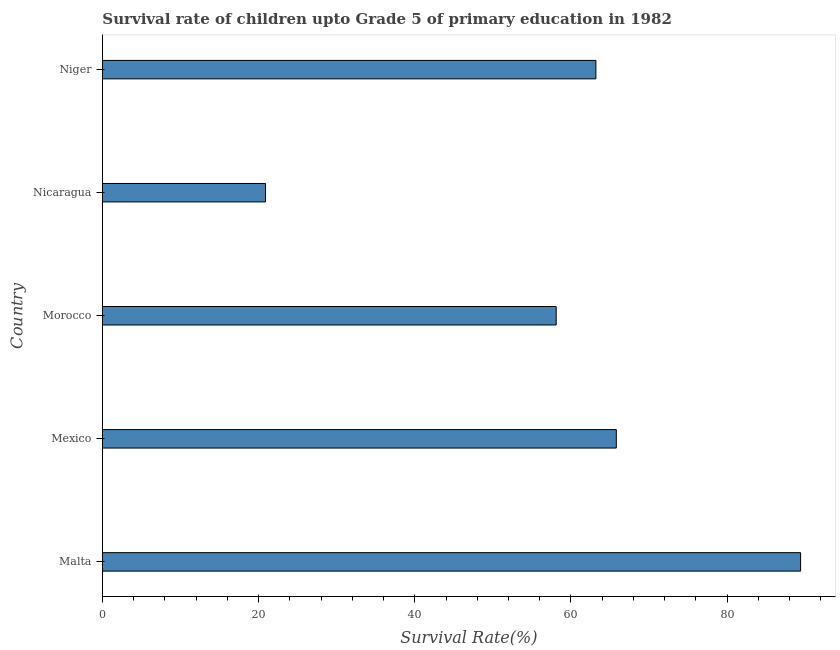Does the graph contain any zero values?
Give a very brief answer. No. Does the graph contain grids?
Your answer should be very brief. No. What is the title of the graph?
Offer a terse response. Survival rate of children upto Grade 5 of primary education in 1982 . What is the label or title of the X-axis?
Ensure brevity in your answer.  Survival Rate(%). What is the survival rate in Niger?
Ensure brevity in your answer.  63.19. Across all countries, what is the maximum survival rate?
Your answer should be compact. 89.4. Across all countries, what is the minimum survival rate?
Provide a short and direct response. 20.88. In which country was the survival rate maximum?
Your answer should be compact. Malta. In which country was the survival rate minimum?
Keep it short and to the point. Nicaragua. What is the sum of the survival rate?
Your answer should be compact. 297.39. What is the difference between the survival rate in Mexico and Niger?
Keep it short and to the point. 2.62. What is the average survival rate per country?
Keep it short and to the point. 59.48. What is the median survival rate?
Your answer should be very brief. 63.19. In how many countries, is the survival rate greater than 24 %?
Your answer should be compact. 4. What is the ratio of the survival rate in Morocco to that in Nicaragua?
Offer a very short reply. 2.78. Is the survival rate in Mexico less than that in Nicaragua?
Your response must be concise. No. What is the difference between the highest and the second highest survival rate?
Your answer should be very brief. 23.6. What is the difference between the highest and the lowest survival rate?
Make the answer very short. 68.52. How many bars are there?
Your response must be concise. 5. How many countries are there in the graph?
Make the answer very short. 5. What is the difference between two consecutive major ticks on the X-axis?
Ensure brevity in your answer.  20. Are the values on the major ticks of X-axis written in scientific E-notation?
Your response must be concise. No. What is the Survival Rate(%) in Malta?
Your answer should be compact. 89.4. What is the Survival Rate(%) in Mexico?
Your answer should be very brief. 65.81. What is the Survival Rate(%) in Morocco?
Your response must be concise. 58.11. What is the Survival Rate(%) in Nicaragua?
Your response must be concise. 20.88. What is the Survival Rate(%) of Niger?
Ensure brevity in your answer.  63.19. What is the difference between the Survival Rate(%) in Malta and Mexico?
Your answer should be very brief. 23.6. What is the difference between the Survival Rate(%) in Malta and Morocco?
Provide a short and direct response. 31.3. What is the difference between the Survival Rate(%) in Malta and Nicaragua?
Ensure brevity in your answer.  68.52. What is the difference between the Survival Rate(%) in Malta and Niger?
Offer a very short reply. 26.22. What is the difference between the Survival Rate(%) in Mexico and Morocco?
Provide a succinct answer. 7.7. What is the difference between the Survival Rate(%) in Mexico and Nicaragua?
Give a very brief answer. 44.93. What is the difference between the Survival Rate(%) in Mexico and Niger?
Give a very brief answer. 2.62. What is the difference between the Survival Rate(%) in Morocco and Nicaragua?
Provide a succinct answer. 37.23. What is the difference between the Survival Rate(%) in Morocco and Niger?
Your response must be concise. -5.08. What is the difference between the Survival Rate(%) in Nicaragua and Niger?
Make the answer very short. -42.31. What is the ratio of the Survival Rate(%) in Malta to that in Mexico?
Offer a terse response. 1.36. What is the ratio of the Survival Rate(%) in Malta to that in Morocco?
Make the answer very short. 1.54. What is the ratio of the Survival Rate(%) in Malta to that in Nicaragua?
Your response must be concise. 4.28. What is the ratio of the Survival Rate(%) in Malta to that in Niger?
Provide a succinct answer. 1.42. What is the ratio of the Survival Rate(%) in Mexico to that in Morocco?
Your response must be concise. 1.13. What is the ratio of the Survival Rate(%) in Mexico to that in Nicaragua?
Provide a short and direct response. 3.15. What is the ratio of the Survival Rate(%) in Mexico to that in Niger?
Give a very brief answer. 1.04. What is the ratio of the Survival Rate(%) in Morocco to that in Nicaragua?
Offer a very short reply. 2.78. What is the ratio of the Survival Rate(%) in Nicaragua to that in Niger?
Your response must be concise. 0.33. 